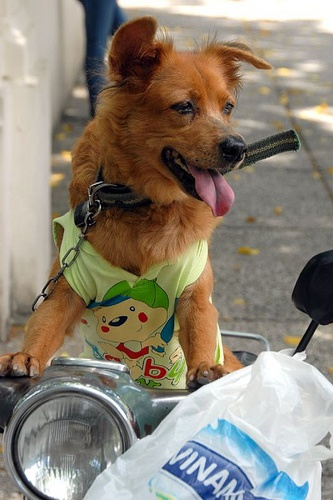Describe the objects in this image and their specific colors. I can see dog in tan, maroon, brown, and black tones, motorcycle in tan, gray, black, darkgray, and white tones, and people in tan, black, navy, blue, and gray tones in this image. 